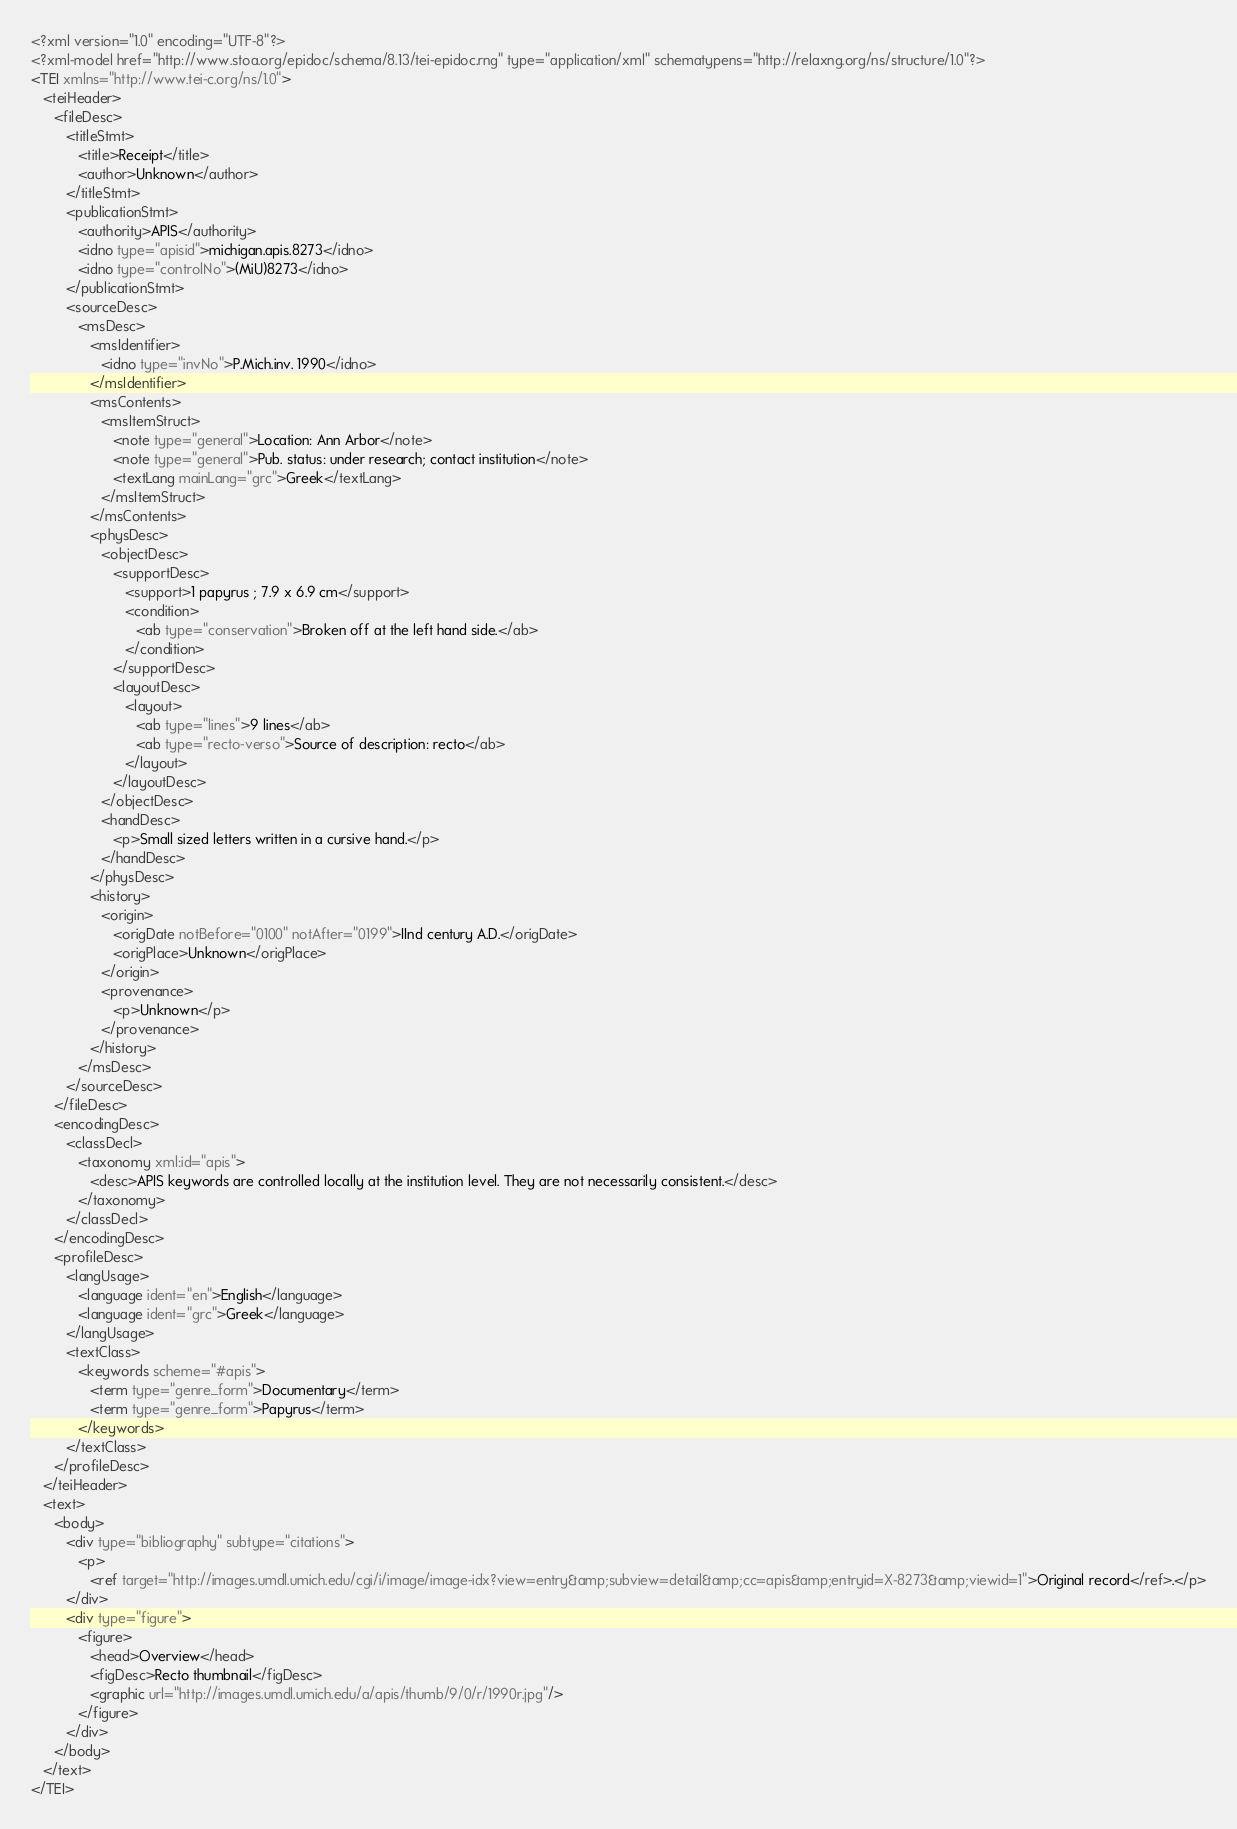<code> <loc_0><loc_0><loc_500><loc_500><_XML_><?xml version="1.0" encoding="UTF-8"?>
<?xml-model href="http://www.stoa.org/epidoc/schema/8.13/tei-epidoc.rng" type="application/xml" schematypens="http://relaxng.org/ns/structure/1.0"?>
<TEI xmlns="http://www.tei-c.org/ns/1.0">
   <teiHeader>
      <fileDesc>
         <titleStmt>
            <title>Receipt</title>
            <author>Unknown</author>
         </titleStmt>
         <publicationStmt>
            <authority>APIS</authority>
            <idno type="apisid">michigan.apis.8273</idno>
            <idno type="controlNo">(MiU)8273</idno>
         </publicationStmt>
         <sourceDesc>
            <msDesc>
               <msIdentifier>
                  <idno type="invNo">P.Mich.inv. 1990</idno>
               </msIdentifier>
               <msContents>
                  <msItemStruct>
                     <note type="general">Location: Ann Arbor</note>
                     <note type="general">Pub. status: under research; contact institution</note>
                     <textLang mainLang="grc">Greek</textLang>
                  </msItemStruct>
               </msContents>
               <physDesc>
                  <objectDesc>
                     <supportDesc>
                        <support>1 papyrus ; 7.9 x 6.9 cm</support>
                        <condition>
                           <ab type="conservation">Broken off at the left hand side.</ab>
                        </condition>
                     </supportDesc>
                     <layoutDesc>
                        <layout>
                           <ab type="lines">9 lines</ab>
                           <ab type="recto-verso">Source of description: recto</ab>
                        </layout>
                     </layoutDesc>
                  </objectDesc>
                  <handDesc>
                     <p>Small sized letters written in a cursive hand.</p>
                  </handDesc>
               </physDesc>
               <history>
                  <origin>
                     <origDate notBefore="0100" notAfter="0199">IInd century A.D.</origDate>
                     <origPlace>Unknown</origPlace>
                  </origin>
                  <provenance>
                     <p>Unknown</p>
                  </provenance>
               </history>
            </msDesc>
         </sourceDesc>
      </fileDesc>
      <encodingDesc>
         <classDecl>
            <taxonomy xml:id="apis">
               <desc>APIS keywords are controlled locally at the institution level. They are not necessarily consistent.</desc>
            </taxonomy>
         </classDecl>
      </encodingDesc>
      <profileDesc>
         <langUsage>
            <language ident="en">English</language>
            <language ident="grc">Greek</language>
         </langUsage>
         <textClass>
            <keywords scheme="#apis">
               <term type="genre_form">Documentary</term>
               <term type="genre_form">Papyrus</term>
            </keywords>
         </textClass>
      </profileDesc>
   </teiHeader>
   <text>
      <body>
         <div type="bibliography" subtype="citations">
            <p>
               <ref target="http://images.umdl.umich.edu/cgi/i/image/image-idx?view=entry&amp;subview=detail&amp;cc=apis&amp;entryid=X-8273&amp;viewid=1">Original record</ref>.</p>
         </div>
         <div type="figure">
            <figure>
               <head>Overview</head>
               <figDesc>Recto thumbnail</figDesc>
               <graphic url="http://images.umdl.umich.edu/a/apis/thumb/9/0/r/1990r.jpg"/>
            </figure>
         </div>
      </body>
   </text>
</TEI>
</code> 